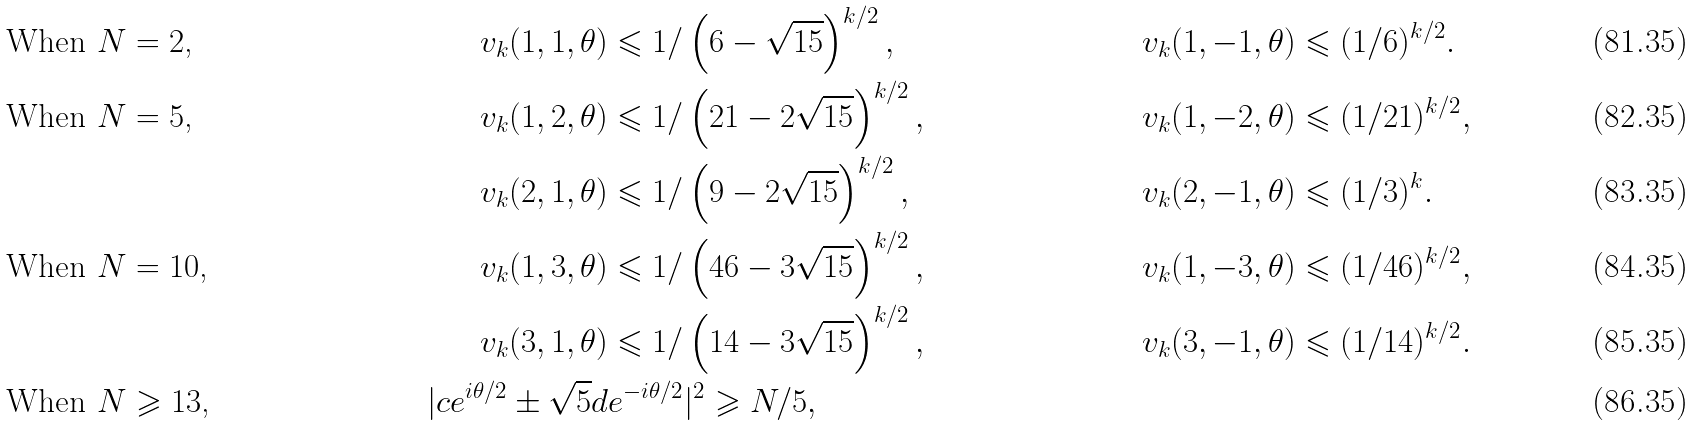<formula> <loc_0><loc_0><loc_500><loc_500>& \text {When $N = 2$,} & v _ { k } ( 1 , 1 , \theta ) & \leqslant 1 / \left ( 6 - \sqrt { 1 5 } \right ) ^ { k / 2 } , \quad & v _ { k } ( 1 , - 1 , \theta ) & \leqslant ( 1 / 6 ) ^ { k / 2 } . \\ & \text {When $N = 5$,} & v _ { k } ( 1 , 2 , \theta ) & \leqslant 1 / \left ( 2 1 - 2 \sqrt { 1 5 } \right ) ^ { k / 2 } , & v _ { k } ( 1 , - 2 , \theta ) & \leqslant ( 1 / 2 1 ) ^ { k / 2 } , \\ & & v _ { k } ( 2 , 1 , \theta ) & \leqslant 1 / \left ( 9 - 2 \sqrt { 1 5 } \right ) ^ { k / 2 } , & v _ { k } ( 2 , - 1 , \theta ) & \leqslant ( 1 / 3 ) ^ { k } . \\ & \text {When $N = 10$,} & v _ { k } ( 1 , 3 , \theta ) & \leqslant 1 / \left ( 4 6 - 3 \sqrt { 1 5 } \right ) ^ { k / 2 } , & v _ { k } ( 1 , - 3 , \theta ) & \leqslant ( 1 / 4 6 ) ^ { k / 2 } , \\ & & v _ { k } ( 3 , 1 , \theta ) & \leqslant 1 / \left ( 1 4 - 3 \sqrt { 1 5 } \right ) ^ { k / 2 } , & v _ { k } ( 3 , - 1 , \theta ) & \leqslant ( 1 / 1 4 ) ^ { k / 2 } . \\ & \text {When $N \geqslant 13$,} & | c e ^ { i \theta / 2 } \pm \sqrt { 5 } d & e ^ { - i \theta / 2 } | ^ { 2 } \geqslant N / 5 ,</formula> 